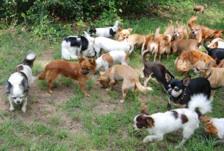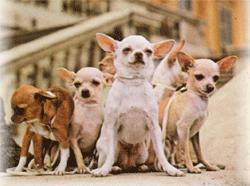The first image is the image on the left, the second image is the image on the right. Analyze the images presented: Is the assertion "At least one dog is wearing a red shirt." valid? Answer yes or no. No. The first image is the image on the left, the second image is the image on the right. Considering the images on both sides, is "In one image, chihuahuas are arranged in a horizontal line with a gray cat toward the middle of the row." valid? Answer yes or no. No. 